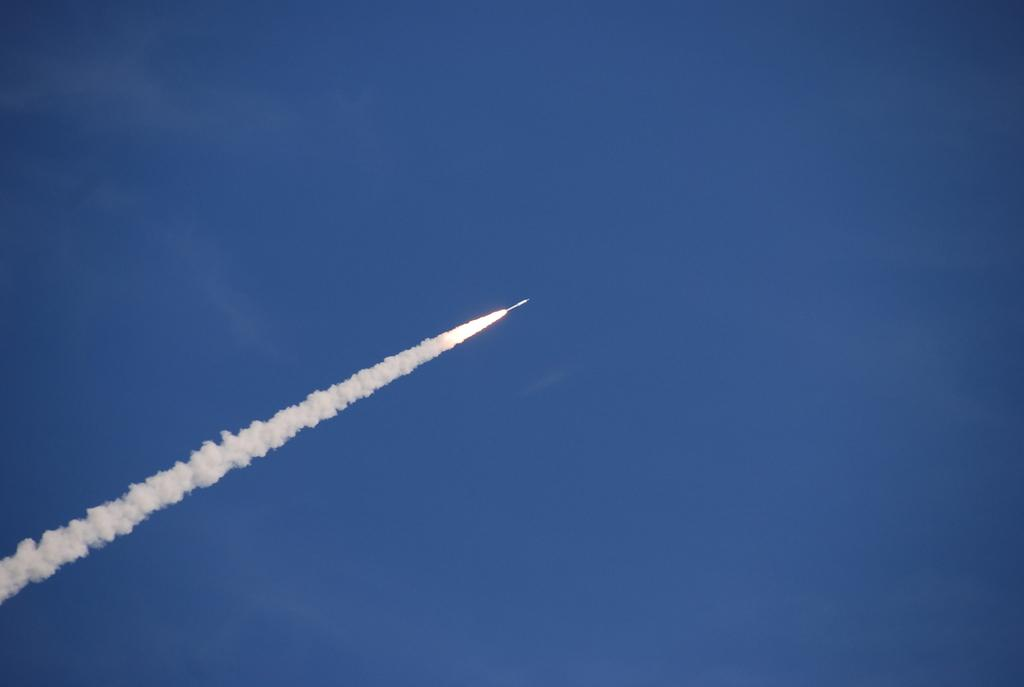What is the main subject of the image? The main subject of the image is a jet. What is happening with the jet in the image? Fire and smoke are visible in the image, suggesting that the jet is experiencing some sort of issue or event. Where are the jet, fire, and smoke located in the image? The jet, fire, and smoke are all in the sky. How many zebras can be seen interacting with the glue on the floor in the image? There are no zebras or glue present in the image. What number is written on the side of the jet in the image? The provided facts do not mention any numbers on the jet, so we cannot determine if there is a number present. 